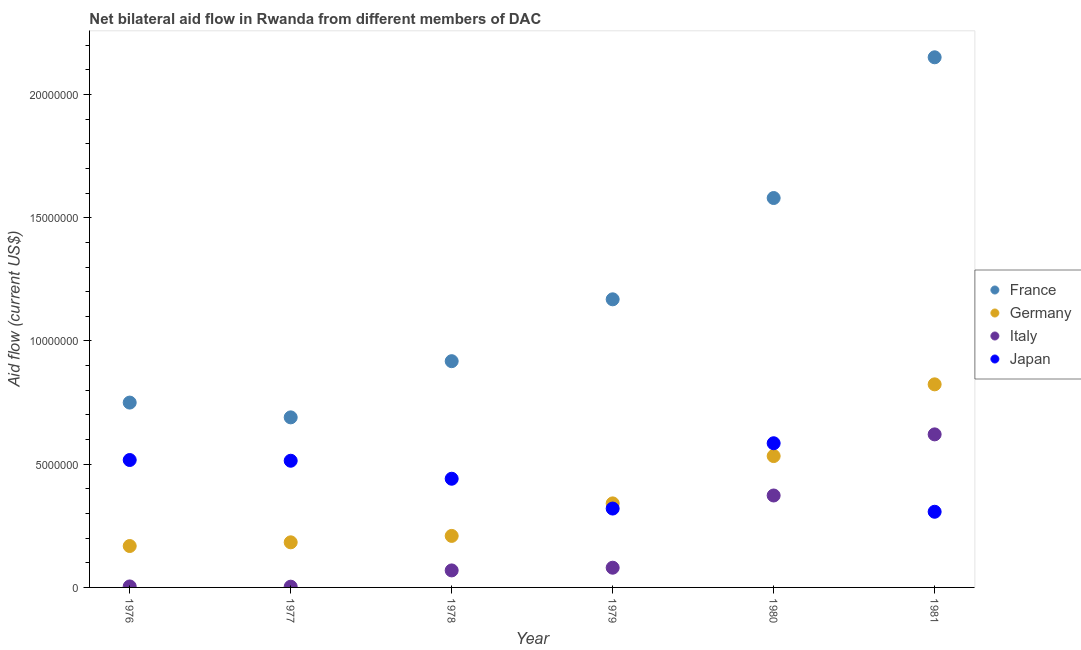How many different coloured dotlines are there?
Your response must be concise. 4. Is the number of dotlines equal to the number of legend labels?
Offer a very short reply. Yes. What is the amount of aid given by italy in 1978?
Give a very brief answer. 6.90e+05. Across all years, what is the maximum amount of aid given by germany?
Make the answer very short. 8.24e+06. Across all years, what is the minimum amount of aid given by italy?
Ensure brevity in your answer.  3.00e+04. In which year was the amount of aid given by germany maximum?
Your response must be concise. 1981. In which year was the amount of aid given by italy minimum?
Your answer should be compact. 1977. What is the total amount of aid given by japan in the graph?
Make the answer very short. 2.68e+07. What is the difference between the amount of aid given by japan in 1979 and that in 1980?
Make the answer very short. -2.65e+06. What is the difference between the amount of aid given by italy in 1978 and the amount of aid given by france in 1980?
Provide a short and direct response. -1.51e+07. What is the average amount of aid given by germany per year?
Give a very brief answer. 3.76e+06. In the year 1981, what is the difference between the amount of aid given by japan and amount of aid given by france?
Make the answer very short. -1.84e+07. In how many years, is the amount of aid given by germany greater than 11000000 US$?
Give a very brief answer. 0. What is the ratio of the amount of aid given by japan in 1977 to that in 1981?
Your response must be concise. 1.67. Is the difference between the amount of aid given by germany in 1976 and 1979 greater than the difference between the amount of aid given by italy in 1976 and 1979?
Provide a succinct answer. No. What is the difference between the highest and the second highest amount of aid given by japan?
Provide a succinct answer. 6.80e+05. What is the difference between the highest and the lowest amount of aid given by italy?
Your answer should be very brief. 6.18e+06. In how many years, is the amount of aid given by germany greater than the average amount of aid given by germany taken over all years?
Offer a terse response. 2. Is it the case that in every year, the sum of the amount of aid given by france and amount of aid given by germany is greater than the amount of aid given by italy?
Keep it short and to the point. Yes. Does the amount of aid given by japan monotonically increase over the years?
Provide a short and direct response. No. How many years are there in the graph?
Ensure brevity in your answer.  6. Are the values on the major ticks of Y-axis written in scientific E-notation?
Offer a very short reply. No. Does the graph contain any zero values?
Your answer should be compact. No. Does the graph contain grids?
Your answer should be compact. No. How many legend labels are there?
Provide a succinct answer. 4. What is the title of the graph?
Ensure brevity in your answer.  Net bilateral aid flow in Rwanda from different members of DAC. Does "Natural Gas" appear as one of the legend labels in the graph?
Provide a succinct answer. No. What is the label or title of the Y-axis?
Your response must be concise. Aid flow (current US$). What is the Aid flow (current US$) of France in 1976?
Your answer should be compact. 7.50e+06. What is the Aid flow (current US$) in Germany in 1976?
Offer a terse response. 1.68e+06. What is the Aid flow (current US$) of Japan in 1976?
Your answer should be compact. 5.17e+06. What is the Aid flow (current US$) of France in 1977?
Your answer should be compact. 6.90e+06. What is the Aid flow (current US$) in Germany in 1977?
Keep it short and to the point. 1.83e+06. What is the Aid flow (current US$) of Japan in 1977?
Ensure brevity in your answer.  5.14e+06. What is the Aid flow (current US$) in France in 1978?
Your answer should be compact. 9.18e+06. What is the Aid flow (current US$) of Germany in 1978?
Your answer should be very brief. 2.09e+06. What is the Aid flow (current US$) in Italy in 1978?
Make the answer very short. 6.90e+05. What is the Aid flow (current US$) of Japan in 1978?
Provide a short and direct response. 4.41e+06. What is the Aid flow (current US$) of France in 1979?
Your answer should be very brief. 1.17e+07. What is the Aid flow (current US$) in Germany in 1979?
Your answer should be very brief. 3.41e+06. What is the Aid flow (current US$) in Japan in 1979?
Make the answer very short. 3.20e+06. What is the Aid flow (current US$) of France in 1980?
Your answer should be compact. 1.58e+07. What is the Aid flow (current US$) in Germany in 1980?
Your answer should be compact. 5.33e+06. What is the Aid flow (current US$) in Italy in 1980?
Offer a terse response. 3.73e+06. What is the Aid flow (current US$) in Japan in 1980?
Provide a short and direct response. 5.85e+06. What is the Aid flow (current US$) in France in 1981?
Keep it short and to the point. 2.15e+07. What is the Aid flow (current US$) in Germany in 1981?
Your answer should be very brief. 8.24e+06. What is the Aid flow (current US$) of Italy in 1981?
Provide a succinct answer. 6.21e+06. What is the Aid flow (current US$) in Japan in 1981?
Keep it short and to the point. 3.07e+06. Across all years, what is the maximum Aid flow (current US$) in France?
Your answer should be very brief. 2.15e+07. Across all years, what is the maximum Aid flow (current US$) in Germany?
Make the answer very short. 8.24e+06. Across all years, what is the maximum Aid flow (current US$) of Italy?
Provide a short and direct response. 6.21e+06. Across all years, what is the maximum Aid flow (current US$) of Japan?
Keep it short and to the point. 5.85e+06. Across all years, what is the minimum Aid flow (current US$) in France?
Offer a terse response. 6.90e+06. Across all years, what is the minimum Aid flow (current US$) of Germany?
Your answer should be compact. 1.68e+06. Across all years, what is the minimum Aid flow (current US$) in Japan?
Give a very brief answer. 3.07e+06. What is the total Aid flow (current US$) in France in the graph?
Ensure brevity in your answer.  7.26e+07. What is the total Aid flow (current US$) in Germany in the graph?
Keep it short and to the point. 2.26e+07. What is the total Aid flow (current US$) of Italy in the graph?
Your answer should be very brief. 1.15e+07. What is the total Aid flow (current US$) of Japan in the graph?
Provide a short and direct response. 2.68e+07. What is the difference between the Aid flow (current US$) of France in 1976 and that in 1978?
Your answer should be compact. -1.68e+06. What is the difference between the Aid flow (current US$) in Germany in 1976 and that in 1978?
Your response must be concise. -4.10e+05. What is the difference between the Aid flow (current US$) in Italy in 1976 and that in 1978?
Your response must be concise. -6.50e+05. What is the difference between the Aid flow (current US$) in Japan in 1976 and that in 1978?
Your response must be concise. 7.60e+05. What is the difference between the Aid flow (current US$) of France in 1976 and that in 1979?
Give a very brief answer. -4.19e+06. What is the difference between the Aid flow (current US$) of Germany in 1976 and that in 1979?
Provide a short and direct response. -1.73e+06. What is the difference between the Aid flow (current US$) of Italy in 1976 and that in 1979?
Provide a succinct answer. -7.60e+05. What is the difference between the Aid flow (current US$) of Japan in 1976 and that in 1979?
Make the answer very short. 1.97e+06. What is the difference between the Aid flow (current US$) of France in 1976 and that in 1980?
Offer a terse response. -8.30e+06. What is the difference between the Aid flow (current US$) in Germany in 1976 and that in 1980?
Your answer should be compact. -3.65e+06. What is the difference between the Aid flow (current US$) in Italy in 1976 and that in 1980?
Offer a terse response. -3.69e+06. What is the difference between the Aid flow (current US$) of Japan in 1976 and that in 1980?
Offer a very short reply. -6.80e+05. What is the difference between the Aid flow (current US$) in France in 1976 and that in 1981?
Your response must be concise. -1.40e+07. What is the difference between the Aid flow (current US$) of Germany in 1976 and that in 1981?
Offer a terse response. -6.56e+06. What is the difference between the Aid flow (current US$) of Italy in 1976 and that in 1981?
Offer a very short reply. -6.17e+06. What is the difference between the Aid flow (current US$) in Japan in 1976 and that in 1981?
Offer a terse response. 2.10e+06. What is the difference between the Aid flow (current US$) of France in 1977 and that in 1978?
Your answer should be very brief. -2.28e+06. What is the difference between the Aid flow (current US$) in Italy in 1977 and that in 1978?
Your answer should be very brief. -6.60e+05. What is the difference between the Aid flow (current US$) of Japan in 1977 and that in 1978?
Your answer should be very brief. 7.30e+05. What is the difference between the Aid flow (current US$) of France in 1977 and that in 1979?
Provide a short and direct response. -4.79e+06. What is the difference between the Aid flow (current US$) in Germany in 1977 and that in 1979?
Keep it short and to the point. -1.58e+06. What is the difference between the Aid flow (current US$) of Italy in 1977 and that in 1979?
Make the answer very short. -7.70e+05. What is the difference between the Aid flow (current US$) in Japan in 1977 and that in 1979?
Give a very brief answer. 1.94e+06. What is the difference between the Aid flow (current US$) of France in 1977 and that in 1980?
Keep it short and to the point. -8.90e+06. What is the difference between the Aid flow (current US$) in Germany in 1977 and that in 1980?
Give a very brief answer. -3.50e+06. What is the difference between the Aid flow (current US$) of Italy in 1977 and that in 1980?
Your answer should be very brief. -3.70e+06. What is the difference between the Aid flow (current US$) of Japan in 1977 and that in 1980?
Provide a short and direct response. -7.10e+05. What is the difference between the Aid flow (current US$) in France in 1977 and that in 1981?
Offer a very short reply. -1.46e+07. What is the difference between the Aid flow (current US$) in Germany in 1977 and that in 1981?
Offer a very short reply. -6.41e+06. What is the difference between the Aid flow (current US$) in Italy in 1977 and that in 1981?
Offer a very short reply. -6.18e+06. What is the difference between the Aid flow (current US$) in Japan in 1977 and that in 1981?
Provide a short and direct response. 2.07e+06. What is the difference between the Aid flow (current US$) of France in 1978 and that in 1979?
Your answer should be compact. -2.51e+06. What is the difference between the Aid flow (current US$) of Germany in 1978 and that in 1979?
Offer a terse response. -1.32e+06. What is the difference between the Aid flow (current US$) in Japan in 1978 and that in 1979?
Your response must be concise. 1.21e+06. What is the difference between the Aid flow (current US$) of France in 1978 and that in 1980?
Your response must be concise. -6.62e+06. What is the difference between the Aid flow (current US$) in Germany in 1978 and that in 1980?
Your answer should be compact. -3.24e+06. What is the difference between the Aid flow (current US$) of Italy in 1978 and that in 1980?
Ensure brevity in your answer.  -3.04e+06. What is the difference between the Aid flow (current US$) in Japan in 1978 and that in 1980?
Ensure brevity in your answer.  -1.44e+06. What is the difference between the Aid flow (current US$) of France in 1978 and that in 1981?
Ensure brevity in your answer.  -1.23e+07. What is the difference between the Aid flow (current US$) in Germany in 1978 and that in 1981?
Ensure brevity in your answer.  -6.15e+06. What is the difference between the Aid flow (current US$) of Italy in 1978 and that in 1981?
Provide a short and direct response. -5.52e+06. What is the difference between the Aid flow (current US$) in Japan in 1978 and that in 1981?
Give a very brief answer. 1.34e+06. What is the difference between the Aid flow (current US$) in France in 1979 and that in 1980?
Give a very brief answer. -4.11e+06. What is the difference between the Aid flow (current US$) in Germany in 1979 and that in 1980?
Provide a succinct answer. -1.92e+06. What is the difference between the Aid flow (current US$) of Italy in 1979 and that in 1980?
Your response must be concise. -2.93e+06. What is the difference between the Aid flow (current US$) of Japan in 1979 and that in 1980?
Offer a very short reply. -2.65e+06. What is the difference between the Aid flow (current US$) of France in 1979 and that in 1981?
Provide a succinct answer. -9.82e+06. What is the difference between the Aid flow (current US$) in Germany in 1979 and that in 1981?
Provide a succinct answer. -4.83e+06. What is the difference between the Aid flow (current US$) in Italy in 1979 and that in 1981?
Your answer should be compact. -5.41e+06. What is the difference between the Aid flow (current US$) of Japan in 1979 and that in 1981?
Keep it short and to the point. 1.30e+05. What is the difference between the Aid flow (current US$) in France in 1980 and that in 1981?
Ensure brevity in your answer.  -5.71e+06. What is the difference between the Aid flow (current US$) of Germany in 1980 and that in 1981?
Your answer should be very brief. -2.91e+06. What is the difference between the Aid flow (current US$) in Italy in 1980 and that in 1981?
Give a very brief answer. -2.48e+06. What is the difference between the Aid flow (current US$) in Japan in 1980 and that in 1981?
Offer a terse response. 2.78e+06. What is the difference between the Aid flow (current US$) of France in 1976 and the Aid flow (current US$) of Germany in 1977?
Provide a short and direct response. 5.67e+06. What is the difference between the Aid flow (current US$) in France in 1976 and the Aid flow (current US$) in Italy in 1977?
Provide a short and direct response. 7.47e+06. What is the difference between the Aid flow (current US$) in France in 1976 and the Aid flow (current US$) in Japan in 1977?
Provide a succinct answer. 2.36e+06. What is the difference between the Aid flow (current US$) in Germany in 1976 and the Aid flow (current US$) in Italy in 1977?
Make the answer very short. 1.65e+06. What is the difference between the Aid flow (current US$) of Germany in 1976 and the Aid flow (current US$) of Japan in 1977?
Provide a succinct answer. -3.46e+06. What is the difference between the Aid flow (current US$) in Italy in 1976 and the Aid flow (current US$) in Japan in 1977?
Provide a succinct answer. -5.10e+06. What is the difference between the Aid flow (current US$) in France in 1976 and the Aid flow (current US$) in Germany in 1978?
Your response must be concise. 5.41e+06. What is the difference between the Aid flow (current US$) of France in 1976 and the Aid flow (current US$) of Italy in 1978?
Offer a terse response. 6.81e+06. What is the difference between the Aid flow (current US$) in France in 1976 and the Aid flow (current US$) in Japan in 1978?
Offer a terse response. 3.09e+06. What is the difference between the Aid flow (current US$) in Germany in 1976 and the Aid flow (current US$) in Italy in 1978?
Provide a succinct answer. 9.90e+05. What is the difference between the Aid flow (current US$) in Germany in 1976 and the Aid flow (current US$) in Japan in 1978?
Your answer should be compact. -2.73e+06. What is the difference between the Aid flow (current US$) in Italy in 1976 and the Aid flow (current US$) in Japan in 1978?
Your answer should be compact. -4.37e+06. What is the difference between the Aid flow (current US$) of France in 1976 and the Aid flow (current US$) of Germany in 1979?
Ensure brevity in your answer.  4.09e+06. What is the difference between the Aid flow (current US$) in France in 1976 and the Aid flow (current US$) in Italy in 1979?
Your answer should be very brief. 6.70e+06. What is the difference between the Aid flow (current US$) of France in 1976 and the Aid flow (current US$) of Japan in 1979?
Ensure brevity in your answer.  4.30e+06. What is the difference between the Aid flow (current US$) of Germany in 1976 and the Aid flow (current US$) of Italy in 1979?
Your answer should be very brief. 8.80e+05. What is the difference between the Aid flow (current US$) of Germany in 1976 and the Aid flow (current US$) of Japan in 1979?
Offer a very short reply. -1.52e+06. What is the difference between the Aid flow (current US$) in Italy in 1976 and the Aid flow (current US$) in Japan in 1979?
Give a very brief answer. -3.16e+06. What is the difference between the Aid flow (current US$) of France in 1976 and the Aid flow (current US$) of Germany in 1980?
Provide a short and direct response. 2.17e+06. What is the difference between the Aid flow (current US$) in France in 1976 and the Aid flow (current US$) in Italy in 1980?
Offer a very short reply. 3.77e+06. What is the difference between the Aid flow (current US$) in France in 1976 and the Aid flow (current US$) in Japan in 1980?
Ensure brevity in your answer.  1.65e+06. What is the difference between the Aid flow (current US$) in Germany in 1976 and the Aid flow (current US$) in Italy in 1980?
Give a very brief answer. -2.05e+06. What is the difference between the Aid flow (current US$) of Germany in 1976 and the Aid flow (current US$) of Japan in 1980?
Provide a succinct answer. -4.17e+06. What is the difference between the Aid flow (current US$) of Italy in 1976 and the Aid flow (current US$) of Japan in 1980?
Keep it short and to the point. -5.81e+06. What is the difference between the Aid flow (current US$) of France in 1976 and the Aid flow (current US$) of Germany in 1981?
Ensure brevity in your answer.  -7.40e+05. What is the difference between the Aid flow (current US$) of France in 1976 and the Aid flow (current US$) of Italy in 1981?
Your response must be concise. 1.29e+06. What is the difference between the Aid flow (current US$) in France in 1976 and the Aid flow (current US$) in Japan in 1981?
Offer a terse response. 4.43e+06. What is the difference between the Aid flow (current US$) of Germany in 1976 and the Aid flow (current US$) of Italy in 1981?
Offer a very short reply. -4.53e+06. What is the difference between the Aid flow (current US$) in Germany in 1976 and the Aid flow (current US$) in Japan in 1981?
Your answer should be compact. -1.39e+06. What is the difference between the Aid flow (current US$) of Italy in 1976 and the Aid flow (current US$) of Japan in 1981?
Provide a short and direct response. -3.03e+06. What is the difference between the Aid flow (current US$) of France in 1977 and the Aid flow (current US$) of Germany in 1978?
Give a very brief answer. 4.81e+06. What is the difference between the Aid flow (current US$) in France in 1977 and the Aid flow (current US$) in Italy in 1978?
Keep it short and to the point. 6.21e+06. What is the difference between the Aid flow (current US$) of France in 1977 and the Aid flow (current US$) of Japan in 1978?
Offer a very short reply. 2.49e+06. What is the difference between the Aid flow (current US$) of Germany in 1977 and the Aid flow (current US$) of Italy in 1978?
Your answer should be very brief. 1.14e+06. What is the difference between the Aid flow (current US$) in Germany in 1977 and the Aid flow (current US$) in Japan in 1978?
Keep it short and to the point. -2.58e+06. What is the difference between the Aid flow (current US$) of Italy in 1977 and the Aid flow (current US$) of Japan in 1978?
Ensure brevity in your answer.  -4.38e+06. What is the difference between the Aid flow (current US$) in France in 1977 and the Aid flow (current US$) in Germany in 1979?
Make the answer very short. 3.49e+06. What is the difference between the Aid flow (current US$) of France in 1977 and the Aid flow (current US$) of Italy in 1979?
Make the answer very short. 6.10e+06. What is the difference between the Aid flow (current US$) of France in 1977 and the Aid flow (current US$) of Japan in 1979?
Your response must be concise. 3.70e+06. What is the difference between the Aid flow (current US$) in Germany in 1977 and the Aid flow (current US$) in Italy in 1979?
Your response must be concise. 1.03e+06. What is the difference between the Aid flow (current US$) in Germany in 1977 and the Aid flow (current US$) in Japan in 1979?
Give a very brief answer. -1.37e+06. What is the difference between the Aid flow (current US$) of Italy in 1977 and the Aid flow (current US$) of Japan in 1979?
Offer a terse response. -3.17e+06. What is the difference between the Aid flow (current US$) in France in 1977 and the Aid flow (current US$) in Germany in 1980?
Ensure brevity in your answer.  1.57e+06. What is the difference between the Aid flow (current US$) in France in 1977 and the Aid flow (current US$) in Italy in 1980?
Provide a short and direct response. 3.17e+06. What is the difference between the Aid flow (current US$) of France in 1977 and the Aid flow (current US$) of Japan in 1980?
Keep it short and to the point. 1.05e+06. What is the difference between the Aid flow (current US$) of Germany in 1977 and the Aid flow (current US$) of Italy in 1980?
Your answer should be very brief. -1.90e+06. What is the difference between the Aid flow (current US$) of Germany in 1977 and the Aid flow (current US$) of Japan in 1980?
Keep it short and to the point. -4.02e+06. What is the difference between the Aid flow (current US$) of Italy in 1977 and the Aid flow (current US$) of Japan in 1980?
Your answer should be compact. -5.82e+06. What is the difference between the Aid flow (current US$) in France in 1977 and the Aid flow (current US$) in Germany in 1981?
Make the answer very short. -1.34e+06. What is the difference between the Aid flow (current US$) of France in 1977 and the Aid flow (current US$) of Italy in 1981?
Offer a very short reply. 6.90e+05. What is the difference between the Aid flow (current US$) of France in 1977 and the Aid flow (current US$) of Japan in 1981?
Give a very brief answer. 3.83e+06. What is the difference between the Aid flow (current US$) in Germany in 1977 and the Aid flow (current US$) in Italy in 1981?
Provide a succinct answer. -4.38e+06. What is the difference between the Aid flow (current US$) in Germany in 1977 and the Aid flow (current US$) in Japan in 1981?
Give a very brief answer. -1.24e+06. What is the difference between the Aid flow (current US$) of Italy in 1977 and the Aid flow (current US$) of Japan in 1981?
Keep it short and to the point. -3.04e+06. What is the difference between the Aid flow (current US$) of France in 1978 and the Aid flow (current US$) of Germany in 1979?
Offer a terse response. 5.77e+06. What is the difference between the Aid flow (current US$) of France in 1978 and the Aid flow (current US$) of Italy in 1979?
Give a very brief answer. 8.38e+06. What is the difference between the Aid flow (current US$) in France in 1978 and the Aid flow (current US$) in Japan in 1979?
Provide a short and direct response. 5.98e+06. What is the difference between the Aid flow (current US$) of Germany in 1978 and the Aid flow (current US$) of Italy in 1979?
Your answer should be compact. 1.29e+06. What is the difference between the Aid flow (current US$) in Germany in 1978 and the Aid flow (current US$) in Japan in 1979?
Provide a succinct answer. -1.11e+06. What is the difference between the Aid flow (current US$) in Italy in 1978 and the Aid flow (current US$) in Japan in 1979?
Make the answer very short. -2.51e+06. What is the difference between the Aid flow (current US$) in France in 1978 and the Aid flow (current US$) in Germany in 1980?
Your response must be concise. 3.85e+06. What is the difference between the Aid flow (current US$) in France in 1978 and the Aid flow (current US$) in Italy in 1980?
Provide a short and direct response. 5.45e+06. What is the difference between the Aid flow (current US$) of France in 1978 and the Aid flow (current US$) of Japan in 1980?
Provide a succinct answer. 3.33e+06. What is the difference between the Aid flow (current US$) of Germany in 1978 and the Aid flow (current US$) of Italy in 1980?
Your answer should be very brief. -1.64e+06. What is the difference between the Aid flow (current US$) in Germany in 1978 and the Aid flow (current US$) in Japan in 1980?
Keep it short and to the point. -3.76e+06. What is the difference between the Aid flow (current US$) of Italy in 1978 and the Aid flow (current US$) of Japan in 1980?
Your answer should be compact. -5.16e+06. What is the difference between the Aid flow (current US$) in France in 1978 and the Aid flow (current US$) in Germany in 1981?
Offer a terse response. 9.40e+05. What is the difference between the Aid flow (current US$) in France in 1978 and the Aid flow (current US$) in Italy in 1981?
Offer a terse response. 2.97e+06. What is the difference between the Aid flow (current US$) of France in 1978 and the Aid flow (current US$) of Japan in 1981?
Your answer should be very brief. 6.11e+06. What is the difference between the Aid flow (current US$) of Germany in 1978 and the Aid flow (current US$) of Italy in 1981?
Offer a terse response. -4.12e+06. What is the difference between the Aid flow (current US$) in Germany in 1978 and the Aid flow (current US$) in Japan in 1981?
Make the answer very short. -9.80e+05. What is the difference between the Aid flow (current US$) in Italy in 1978 and the Aid flow (current US$) in Japan in 1981?
Your answer should be very brief. -2.38e+06. What is the difference between the Aid flow (current US$) in France in 1979 and the Aid flow (current US$) in Germany in 1980?
Keep it short and to the point. 6.36e+06. What is the difference between the Aid flow (current US$) in France in 1979 and the Aid flow (current US$) in Italy in 1980?
Ensure brevity in your answer.  7.96e+06. What is the difference between the Aid flow (current US$) in France in 1979 and the Aid flow (current US$) in Japan in 1980?
Give a very brief answer. 5.84e+06. What is the difference between the Aid flow (current US$) of Germany in 1979 and the Aid flow (current US$) of Italy in 1980?
Offer a very short reply. -3.20e+05. What is the difference between the Aid flow (current US$) of Germany in 1979 and the Aid flow (current US$) of Japan in 1980?
Provide a short and direct response. -2.44e+06. What is the difference between the Aid flow (current US$) of Italy in 1979 and the Aid flow (current US$) of Japan in 1980?
Offer a very short reply. -5.05e+06. What is the difference between the Aid flow (current US$) of France in 1979 and the Aid flow (current US$) of Germany in 1981?
Offer a very short reply. 3.45e+06. What is the difference between the Aid flow (current US$) in France in 1979 and the Aid flow (current US$) in Italy in 1981?
Provide a short and direct response. 5.48e+06. What is the difference between the Aid flow (current US$) in France in 1979 and the Aid flow (current US$) in Japan in 1981?
Offer a terse response. 8.62e+06. What is the difference between the Aid flow (current US$) of Germany in 1979 and the Aid flow (current US$) of Italy in 1981?
Provide a short and direct response. -2.80e+06. What is the difference between the Aid flow (current US$) of Germany in 1979 and the Aid flow (current US$) of Japan in 1981?
Your response must be concise. 3.40e+05. What is the difference between the Aid flow (current US$) in Italy in 1979 and the Aid flow (current US$) in Japan in 1981?
Offer a very short reply. -2.27e+06. What is the difference between the Aid flow (current US$) of France in 1980 and the Aid flow (current US$) of Germany in 1981?
Give a very brief answer. 7.56e+06. What is the difference between the Aid flow (current US$) in France in 1980 and the Aid flow (current US$) in Italy in 1981?
Your answer should be very brief. 9.59e+06. What is the difference between the Aid flow (current US$) of France in 1980 and the Aid flow (current US$) of Japan in 1981?
Provide a short and direct response. 1.27e+07. What is the difference between the Aid flow (current US$) in Germany in 1980 and the Aid flow (current US$) in Italy in 1981?
Give a very brief answer. -8.80e+05. What is the difference between the Aid flow (current US$) in Germany in 1980 and the Aid flow (current US$) in Japan in 1981?
Offer a terse response. 2.26e+06. What is the difference between the Aid flow (current US$) of Italy in 1980 and the Aid flow (current US$) of Japan in 1981?
Make the answer very short. 6.60e+05. What is the average Aid flow (current US$) of France per year?
Your response must be concise. 1.21e+07. What is the average Aid flow (current US$) of Germany per year?
Provide a short and direct response. 3.76e+06. What is the average Aid flow (current US$) in Italy per year?
Offer a very short reply. 1.92e+06. What is the average Aid flow (current US$) of Japan per year?
Keep it short and to the point. 4.47e+06. In the year 1976, what is the difference between the Aid flow (current US$) in France and Aid flow (current US$) in Germany?
Offer a terse response. 5.82e+06. In the year 1976, what is the difference between the Aid flow (current US$) of France and Aid flow (current US$) of Italy?
Your answer should be compact. 7.46e+06. In the year 1976, what is the difference between the Aid flow (current US$) in France and Aid flow (current US$) in Japan?
Keep it short and to the point. 2.33e+06. In the year 1976, what is the difference between the Aid flow (current US$) of Germany and Aid flow (current US$) of Italy?
Offer a very short reply. 1.64e+06. In the year 1976, what is the difference between the Aid flow (current US$) in Germany and Aid flow (current US$) in Japan?
Your response must be concise. -3.49e+06. In the year 1976, what is the difference between the Aid flow (current US$) in Italy and Aid flow (current US$) in Japan?
Provide a short and direct response. -5.13e+06. In the year 1977, what is the difference between the Aid flow (current US$) in France and Aid flow (current US$) in Germany?
Your answer should be compact. 5.07e+06. In the year 1977, what is the difference between the Aid flow (current US$) in France and Aid flow (current US$) in Italy?
Provide a short and direct response. 6.87e+06. In the year 1977, what is the difference between the Aid flow (current US$) of France and Aid flow (current US$) of Japan?
Keep it short and to the point. 1.76e+06. In the year 1977, what is the difference between the Aid flow (current US$) in Germany and Aid flow (current US$) in Italy?
Ensure brevity in your answer.  1.80e+06. In the year 1977, what is the difference between the Aid flow (current US$) of Germany and Aid flow (current US$) of Japan?
Your answer should be compact. -3.31e+06. In the year 1977, what is the difference between the Aid flow (current US$) of Italy and Aid flow (current US$) of Japan?
Your response must be concise. -5.11e+06. In the year 1978, what is the difference between the Aid flow (current US$) in France and Aid flow (current US$) in Germany?
Keep it short and to the point. 7.09e+06. In the year 1978, what is the difference between the Aid flow (current US$) of France and Aid flow (current US$) of Italy?
Offer a terse response. 8.49e+06. In the year 1978, what is the difference between the Aid flow (current US$) in France and Aid flow (current US$) in Japan?
Your answer should be very brief. 4.77e+06. In the year 1978, what is the difference between the Aid flow (current US$) in Germany and Aid flow (current US$) in Italy?
Your answer should be compact. 1.40e+06. In the year 1978, what is the difference between the Aid flow (current US$) in Germany and Aid flow (current US$) in Japan?
Give a very brief answer. -2.32e+06. In the year 1978, what is the difference between the Aid flow (current US$) in Italy and Aid flow (current US$) in Japan?
Offer a terse response. -3.72e+06. In the year 1979, what is the difference between the Aid flow (current US$) in France and Aid flow (current US$) in Germany?
Your answer should be compact. 8.28e+06. In the year 1979, what is the difference between the Aid flow (current US$) of France and Aid flow (current US$) of Italy?
Ensure brevity in your answer.  1.09e+07. In the year 1979, what is the difference between the Aid flow (current US$) in France and Aid flow (current US$) in Japan?
Your answer should be compact. 8.49e+06. In the year 1979, what is the difference between the Aid flow (current US$) of Germany and Aid flow (current US$) of Italy?
Offer a terse response. 2.61e+06. In the year 1979, what is the difference between the Aid flow (current US$) in Italy and Aid flow (current US$) in Japan?
Provide a short and direct response. -2.40e+06. In the year 1980, what is the difference between the Aid flow (current US$) in France and Aid flow (current US$) in Germany?
Keep it short and to the point. 1.05e+07. In the year 1980, what is the difference between the Aid flow (current US$) of France and Aid flow (current US$) of Italy?
Your answer should be compact. 1.21e+07. In the year 1980, what is the difference between the Aid flow (current US$) of France and Aid flow (current US$) of Japan?
Your answer should be compact. 9.95e+06. In the year 1980, what is the difference between the Aid flow (current US$) of Germany and Aid flow (current US$) of Italy?
Give a very brief answer. 1.60e+06. In the year 1980, what is the difference between the Aid flow (current US$) in Germany and Aid flow (current US$) in Japan?
Provide a succinct answer. -5.20e+05. In the year 1980, what is the difference between the Aid flow (current US$) in Italy and Aid flow (current US$) in Japan?
Provide a succinct answer. -2.12e+06. In the year 1981, what is the difference between the Aid flow (current US$) of France and Aid flow (current US$) of Germany?
Your response must be concise. 1.33e+07. In the year 1981, what is the difference between the Aid flow (current US$) in France and Aid flow (current US$) in Italy?
Offer a terse response. 1.53e+07. In the year 1981, what is the difference between the Aid flow (current US$) in France and Aid flow (current US$) in Japan?
Offer a terse response. 1.84e+07. In the year 1981, what is the difference between the Aid flow (current US$) of Germany and Aid flow (current US$) of Italy?
Your answer should be very brief. 2.03e+06. In the year 1981, what is the difference between the Aid flow (current US$) of Germany and Aid flow (current US$) of Japan?
Offer a terse response. 5.17e+06. In the year 1981, what is the difference between the Aid flow (current US$) in Italy and Aid flow (current US$) in Japan?
Make the answer very short. 3.14e+06. What is the ratio of the Aid flow (current US$) of France in 1976 to that in 1977?
Your answer should be very brief. 1.09. What is the ratio of the Aid flow (current US$) in Germany in 1976 to that in 1977?
Provide a short and direct response. 0.92. What is the ratio of the Aid flow (current US$) of Italy in 1976 to that in 1977?
Make the answer very short. 1.33. What is the ratio of the Aid flow (current US$) of France in 1976 to that in 1978?
Ensure brevity in your answer.  0.82. What is the ratio of the Aid flow (current US$) of Germany in 1976 to that in 1978?
Give a very brief answer. 0.8. What is the ratio of the Aid flow (current US$) in Italy in 1976 to that in 1978?
Offer a very short reply. 0.06. What is the ratio of the Aid flow (current US$) of Japan in 1976 to that in 1978?
Provide a succinct answer. 1.17. What is the ratio of the Aid flow (current US$) of France in 1976 to that in 1979?
Make the answer very short. 0.64. What is the ratio of the Aid flow (current US$) of Germany in 1976 to that in 1979?
Make the answer very short. 0.49. What is the ratio of the Aid flow (current US$) of Japan in 1976 to that in 1979?
Your answer should be compact. 1.62. What is the ratio of the Aid flow (current US$) of France in 1976 to that in 1980?
Ensure brevity in your answer.  0.47. What is the ratio of the Aid flow (current US$) in Germany in 1976 to that in 1980?
Offer a very short reply. 0.32. What is the ratio of the Aid flow (current US$) in Italy in 1976 to that in 1980?
Your answer should be compact. 0.01. What is the ratio of the Aid flow (current US$) in Japan in 1976 to that in 1980?
Offer a terse response. 0.88. What is the ratio of the Aid flow (current US$) of France in 1976 to that in 1981?
Keep it short and to the point. 0.35. What is the ratio of the Aid flow (current US$) in Germany in 1976 to that in 1981?
Provide a succinct answer. 0.2. What is the ratio of the Aid flow (current US$) in Italy in 1976 to that in 1981?
Give a very brief answer. 0.01. What is the ratio of the Aid flow (current US$) of Japan in 1976 to that in 1981?
Make the answer very short. 1.68. What is the ratio of the Aid flow (current US$) of France in 1977 to that in 1978?
Offer a very short reply. 0.75. What is the ratio of the Aid flow (current US$) of Germany in 1977 to that in 1978?
Provide a short and direct response. 0.88. What is the ratio of the Aid flow (current US$) of Italy in 1977 to that in 1978?
Offer a terse response. 0.04. What is the ratio of the Aid flow (current US$) of Japan in 1977 to that in 1978?
Your answer should be very brief. 1.17. What is the ratio of the Aid flow (current US$) of France in 1977 to that in 1979?
Your answer should be compact. 0.59. What is the ratio of the Aid flow (current US$) of Germany in 1977 to that in 1979?
Your answer should be very brief. 0.54. What is the ratio of the Aid flow (current US$) of Italy in 1977 to that in 1979?
Your response must be concise. 0.04. What is the ratio of the Aid flow (current US$) of Japan in 1977 to that in 1979?
Offer a terse response. 1.61. What is the ratio of the Aid flow (current US$) in France in 1977 to that in 1980?
Your response must be concise. 0.44. What is the ratio of the Aid flow (current US$) of Germany in 1977 to that in 1980?
Provide a succinct answer. 0.34. What is the ratio of the Aid flow (current US$) of Italy in 1977 to that in 1980?
Give a very brief answer. 0.01. What is the ratio of the Aid flow (current US$) of Japan in 1977 to that in 1980?
Offer a very short reply. 0.88. What is the ratio of the Aid flow (current US$) in France in 1977 to that in 1981?
Offer a very short reply. 0.32. What is the ratio of the Aid flow (current US$) in Germany in 1977 to that in 1981?
Ensure brevity in your answer.  0.22. What is the ratio of the Aid flow (current US$) in Italy in 1977 to that in 1981?
Your response must be concise. 0. What is the ratio of the Aid flow (current US$) of Japan in 1977 to that in 1981?
Your answer should be very brief. 1.67. What is the ratio of the Aid flow (current US$) in France in 1978 to that in 1979?
Give a very brief answer. 0.79. What is the ratio of the Aid flow (current US$) in Germany in 1978 to that in 1979?
Your answer should be compact. 0.61. What is the ratio of the Aid flow (current US$) in Italy in 1978 to that in 1979?
Make the answer very short. 0.86. What is the ratio of the Aid flow (current US$) of Japan in 1978 to that in 1979?
Your answer should be compact. 1.38. What is the ratio of the Aid flow (current US$) in France in 1978 to that in 1980?
Your answer should be compact. 0.58. What is the ratio of the Aid flow (current US$) in Germany in 1978 to that in 1980?
Your answer should be compact. 0.39. What is the ratio of the Aid flow (current US$) in Italy in 1978 to that in 1980?
Your answer should be compact. 0.18. What is the ratio of the Aid flow (current US$) in Japan in 1978 to that in 1980?
Offer a terse response. 0.75. What is the ratio of the Aid flow (current US$) in France in 1978 to that in 1981?
Keep it short and to the point. 0.43. What is the ratio of the Aid flow (current US$) in Germany in 1978 to that in 1981?
Keep it short and to the point. 0.25. What is the ratio of the Aid flow (current US$) in Japan in 1978 to that in 1981?
Your response must be concise. 1.44. What is the ratio of the Aid flow (current US$) of France in 1979 to that in 1980?
Your response must be concise. 0.74. What is the ratio of the Aid flow (current US$) of Germany in 1979 to that in 1980?
Ensure brevity in your answer.  0.64. What is the ratio of the Aid flow (current US$) in Italy in 1979 to that in 1980?
Ensure brevity in your answer.  0.21. What is the ratio of the Aid flow (current US$) in Japan in 1979 to that in 1980?
Keep it short and to the point. 0.55. What is the ratio of the Aid flow (current US$) in France in 1979 to that in 1981?
Your answer should be compact. 0.54. What is the ratio of the Aid flow (current US$) of Germany in 1979 to that in 1981?
Offer a very short reply. 0.41. What is the ratio of the Aid flow (current US$) of Italy in 1979 to that in 1981?
Offer a very short reply. 0.13. What is the ratio of the Aid flow (current US$) in Japan in 1979 to that in 1981?
Keep it short and to the point. 1.04. What is the ratio of the Aid flow (current US$) in France in 1980 to that in 1981?
Keep it short and to the point. 0.73. What is the ratio of the Aid flow (current US$) of Germany in 1980 to that in 1981?
Give a very brief answer. 0.65. What is the ratio of the Aid flow (current US$) of Italy in 1980 to that in 1981?
Keep it short and to the point. 0.6. What is the ratio of the Aid flow (current US$) in Japan in 1980 to that in 1981?
Offer a very short reply. 1.91. What is the difference between the highest and the second highest Aid flow (current US$) of France?
Your answer should be compact. 5.71e+06. What is the difference between the highest and the second highest Aid flow (current US$) in Germany?
Offer a very short reply. 2.91e+06. What is the difference between the highest and the second highest Aid flow (current US$) of Italy?
Give a very brief answer. 2.48e+06. What is the difference between the highest and the second highest Aid flow (current US$) of Japan?
Provide a succinct answer. 6.80e+05. What is the difference between the highest and the lowest Aid flow (current US$) in France?
Give a very brief answer. 1.46e+07. What is the difference between the highest and the lowest Aid flow (current US$) in Germany?
Your response must be concise. 6.56e+06. What is the difference between the highest and the lowest Aid flow (current US$) of Italy?
Offer a very short reply. 6.18e+06. What is the difference between the highest and the lowest Aid flow (current US$) in Japan?
Keep it short and to the point. 2.78e+06. 